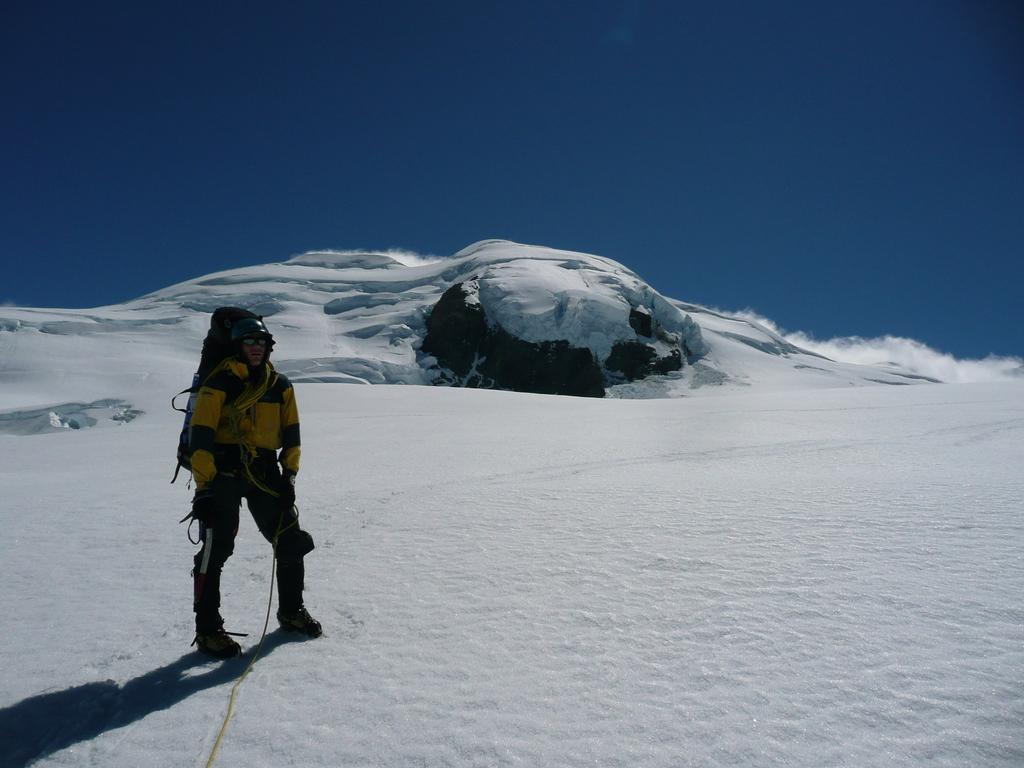Can you describe this image briefly? In the front of the image we can see a person and land is covered with snow. In the background there is a blue sky. 